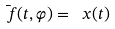Convert formula to latex. <formula><loc_0><loc_0><loc_500><loc_500>\bar { \ f } ( t , \varphi ) = { \ x } ( t )</formula> 